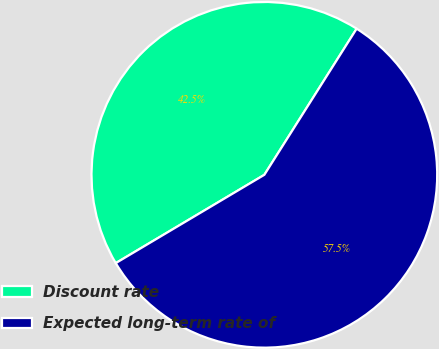Convert chart to OTSL. <chart><loc_0><loc_0><loc_500><loc_500><pie_chart><fcel>Discount rate<fcel>Expected long-term rate of<nl><fcel>42.5%<fcel>57.5%<nl></chart> 